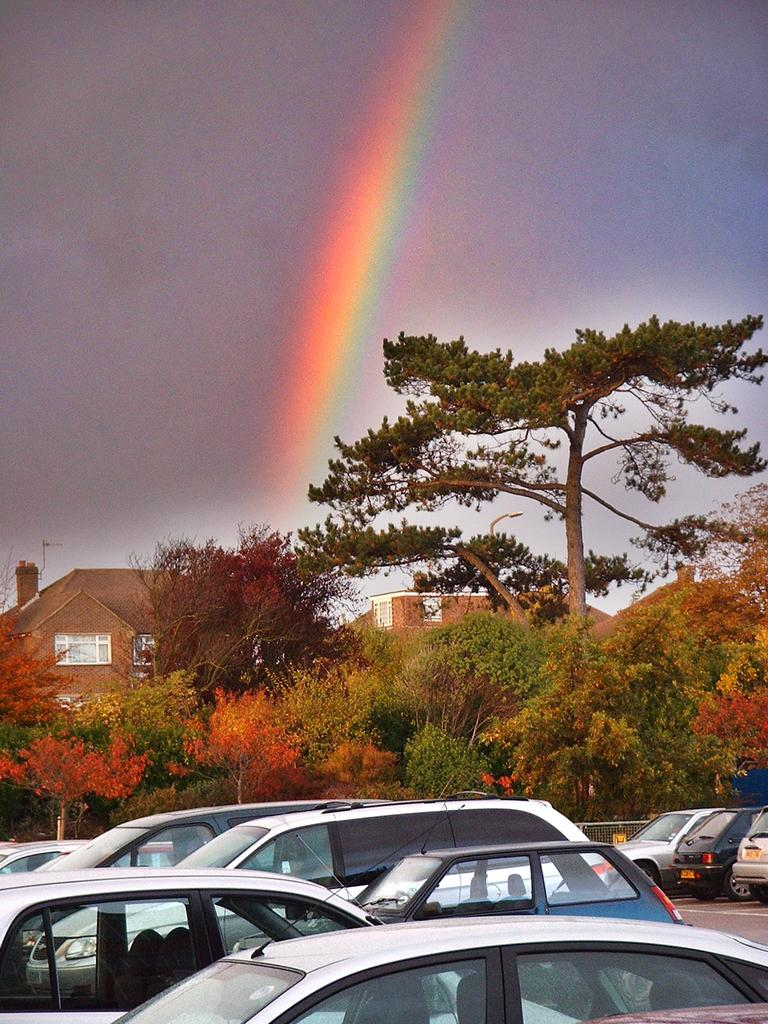What can be seen parked in the image? There are cars parked in the image. What type of natural elements are visible in the image? There are trees visible in the image. What type of man-made structures are present in the image? There are buildings in the image. What is visible in the sky in the image? The sky is visible in the image, and there is a rainbow in the sky. What type of competition is taking place in the image? There is no competition present in the image. Can you describe the police presence in the image? There is no police presence in the image. 